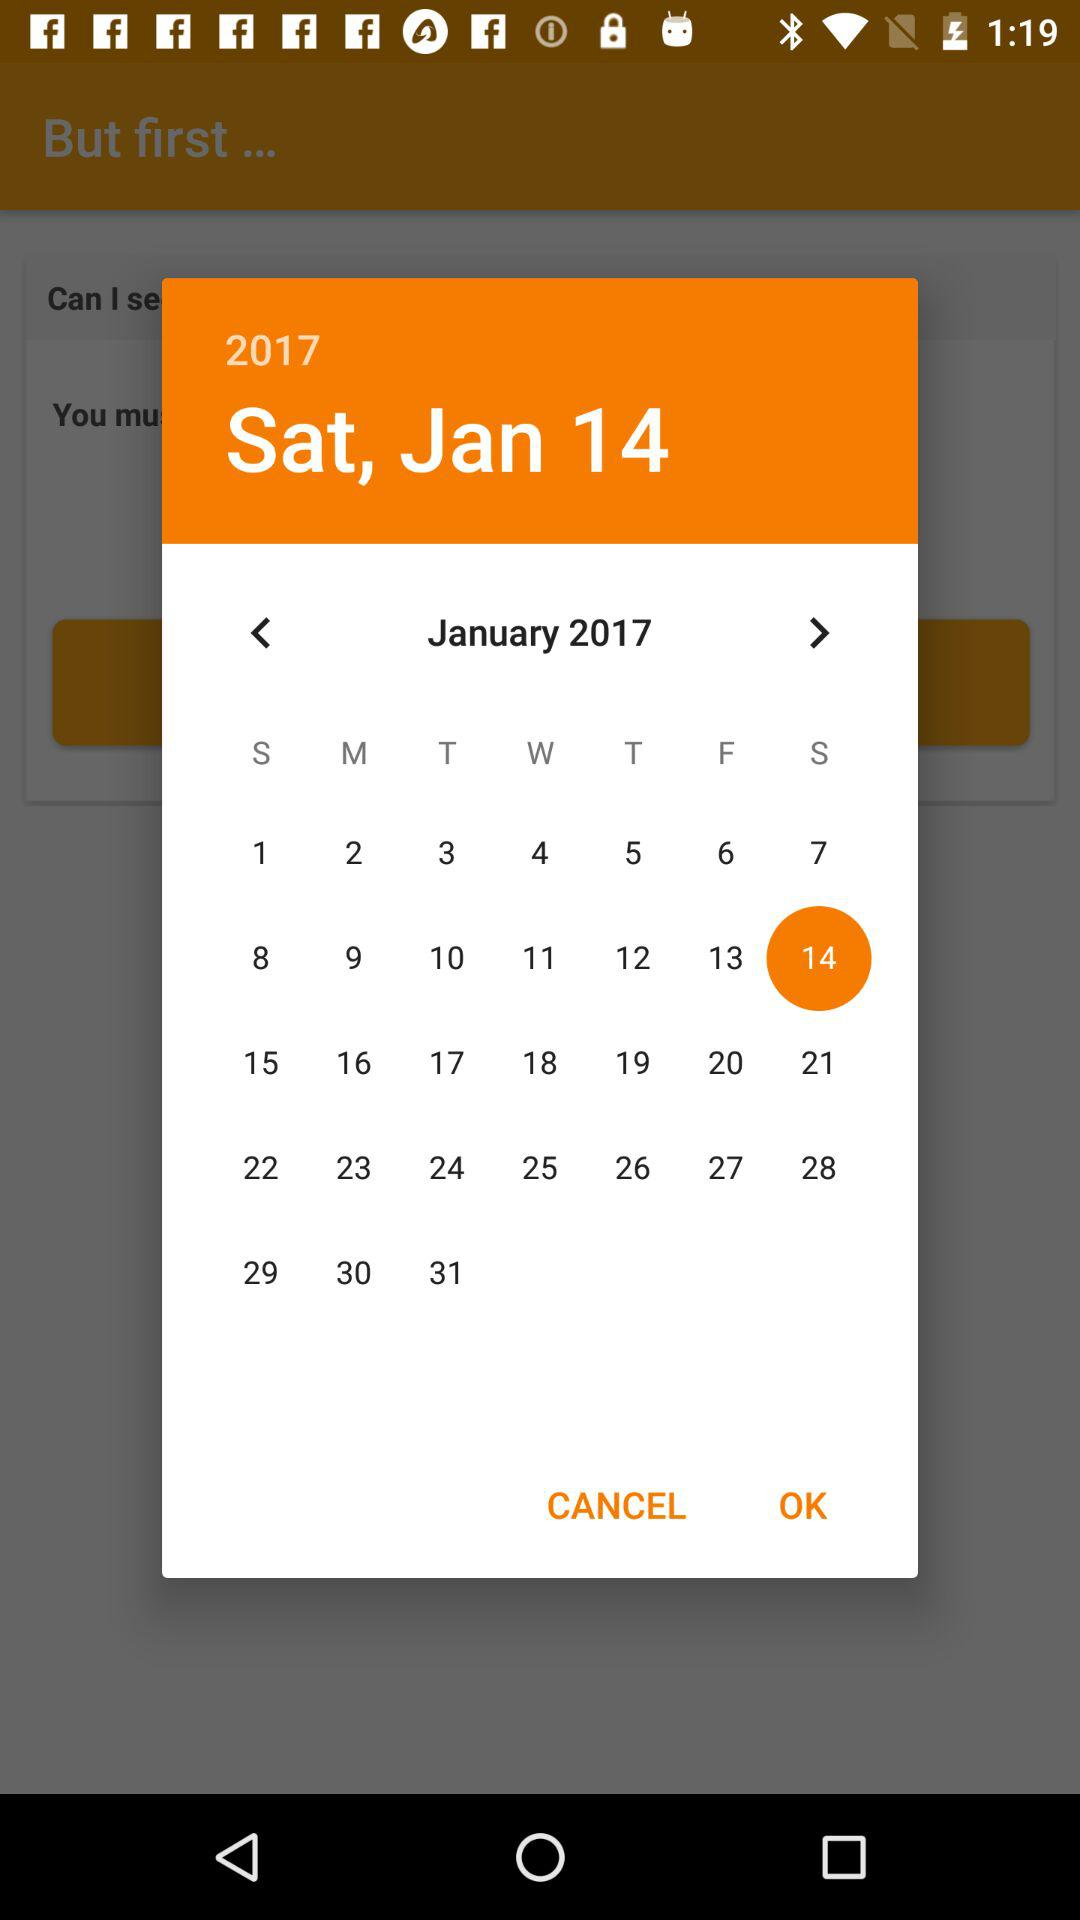Which dates fall on Wednesday, January, 2017? The dates that fall on Wednesday, January, 2017 are 4, 11, 18 and 25. 